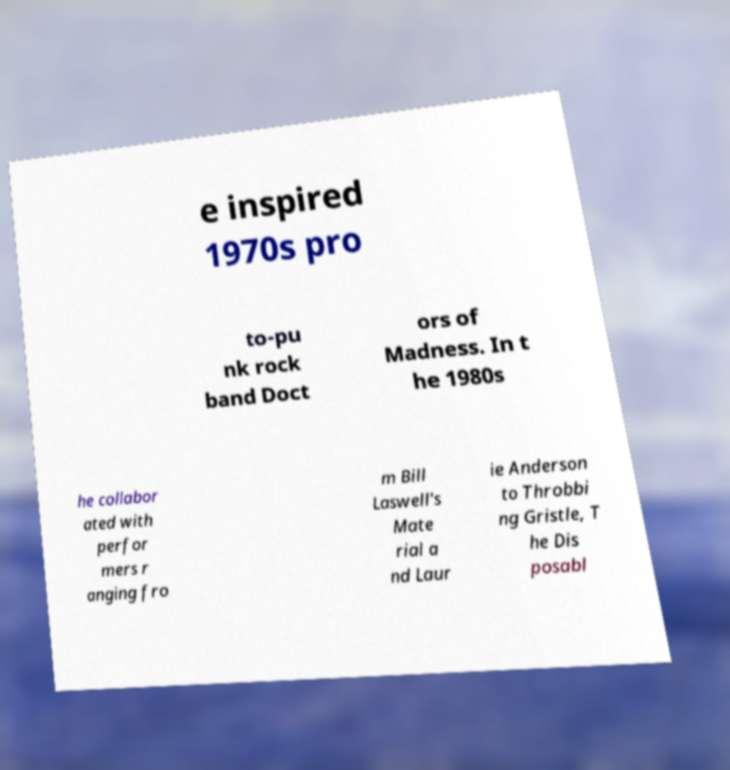Could you assist in decoding the text presented in this image and type it out clearly? e inspired 1970s pro to-pu nk rock band Doct ors of Madness. In t he 1980s he collabor ated with perfor mers r anging fro m Bill Laswell's Mate rial a nd Laur ie Anderson to Throbbi ng Gristle, T he Dis posabl 